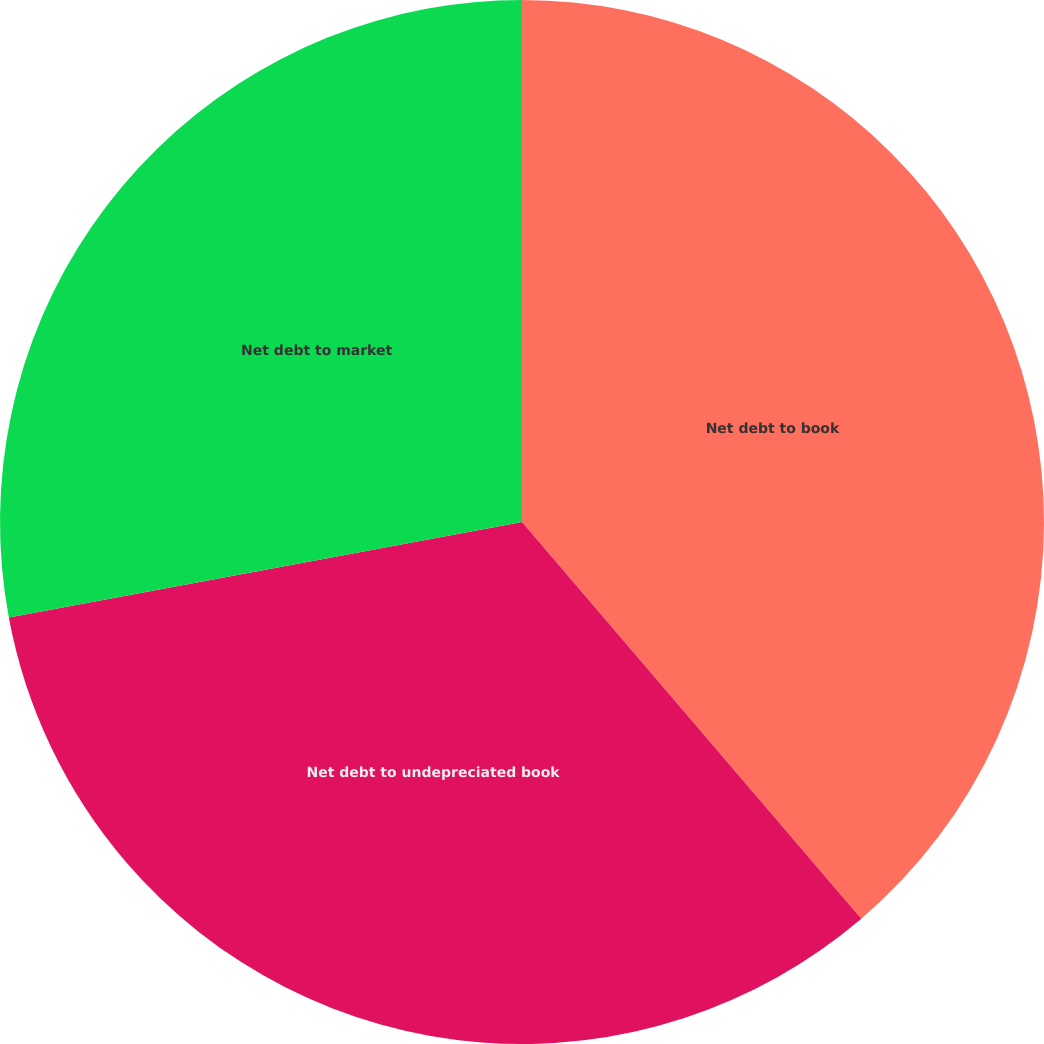Convert chart. <chart><loc_0><loc_0><loc_500><loc_500><pie_chart><fcel>Net debt to book<fcel>Net debt to undepreciated book<fcel>Net debt to market<nl><fcel>38.74%<fcel>33.33%<fcel>27.93%<nl></chart> 